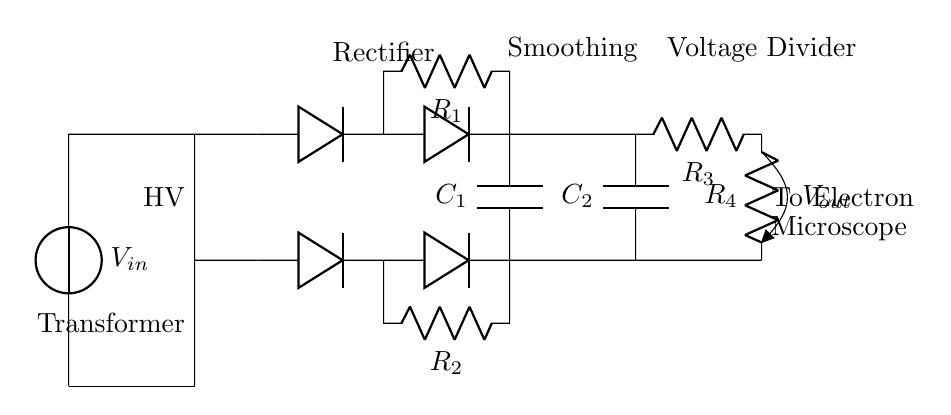What is the input voltage of the circuit? The input voltage is represented by the voltage source labeled V_in, as shown on the left side of the circuit.
Answer: V_in What components are used for rectification in this circuit? The rectification is done using diodes, which are shown in the schematic as Do. There are four diodes arranged in a bridge configuration for full-wave rectification.
Answer: Diodes Which component is responsible for smoothing the output voltage? The smoothing capacitors, labeled as C_1 and C_2, are connected in parallel to the output terminals and help reduce voltage fluctuations.
Answer: C_1 and C_2 What is the purpose of the voltage divider in this circuit? The voltage divider, consisting of resistors R_3 and R_4, is used to reduce the output voltage to the desired level for the electron microscope.
Answer: To reduce output voltage How do resistors R_1 and R_2 function in the circuit? Resistors R_1 and R_2 are used in series with the diodes in the rectifier section to limit the current and protect the circuit components from excessive current flow.
Answer: Current limiting What is the connection configuration of the diodes in the rectifier bridge? The diodes are arranged in a bridge configuration, allowing for the conversion of both halves of the AC input signal into a DC output.
Answer: Bridge configuration What determines the high voltage in this power supply circuit? The high voltage is primarily determined by the transformer, which steps up the input voltage to a higher level suitable for the electron microscope's operation.
Answer: Transformer 